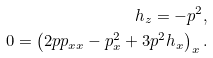Convert formula to latex. <formula><loc_0><loc_0><loc_500><loc_500>h _ { z } = - p ^ { 2 } , \\ 0 = \left ( 2 p p _ { x x } - p _ { x } ^ { 2 } + 3 p ^ { 2 } h _ { x } \right ) _ { x } .</formula> 